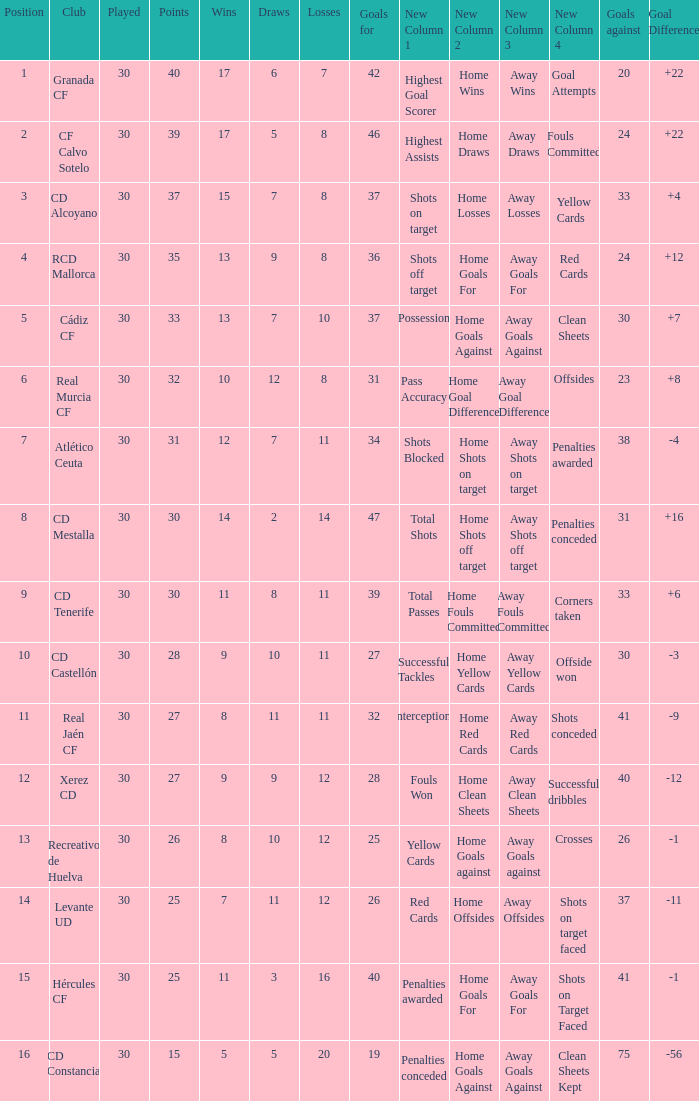How many Wins have Goals against smaller than 30, and Goals for larger than 25, and Draws larger than 5? 3.0. 